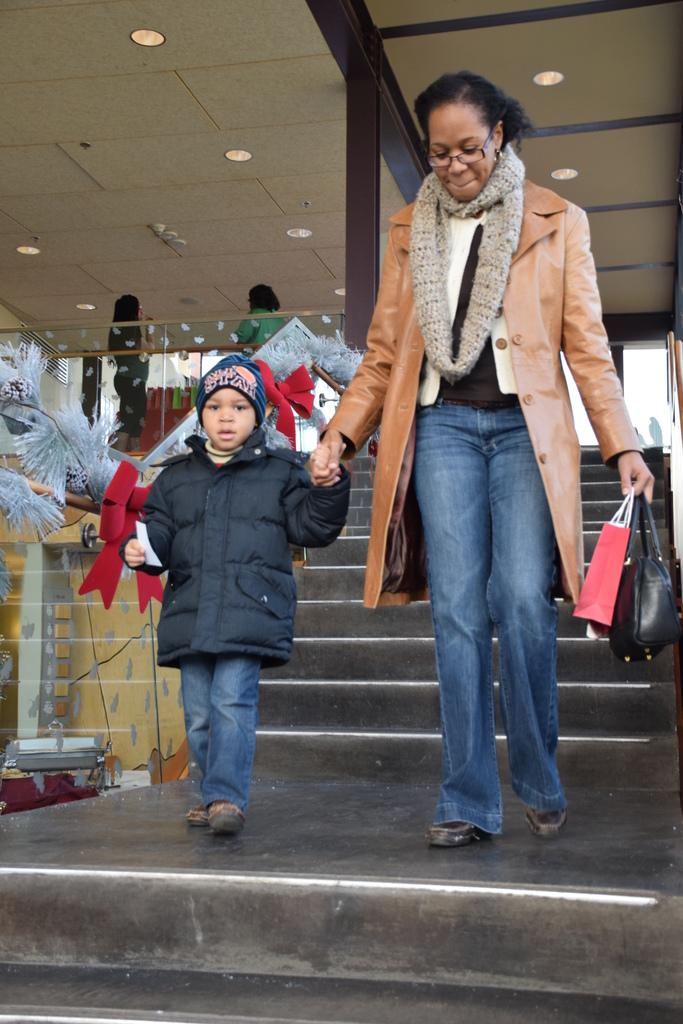Who is present in the image? There is a woman and a child in the image. What is the woman holding? The woman is holding bags and the hand of a child. Where are they located? They are on a path. What can be seen in the background of the image? There are 2 persons, stairs, and lights on the ceiling in the background of the image. What type of bone can be seen in the image? There is no bone present in the image. How many elbows can be seen in the image? The number of elbows cannot be determined from the image, as it only shows the woman holding the child's hand and the bags. 